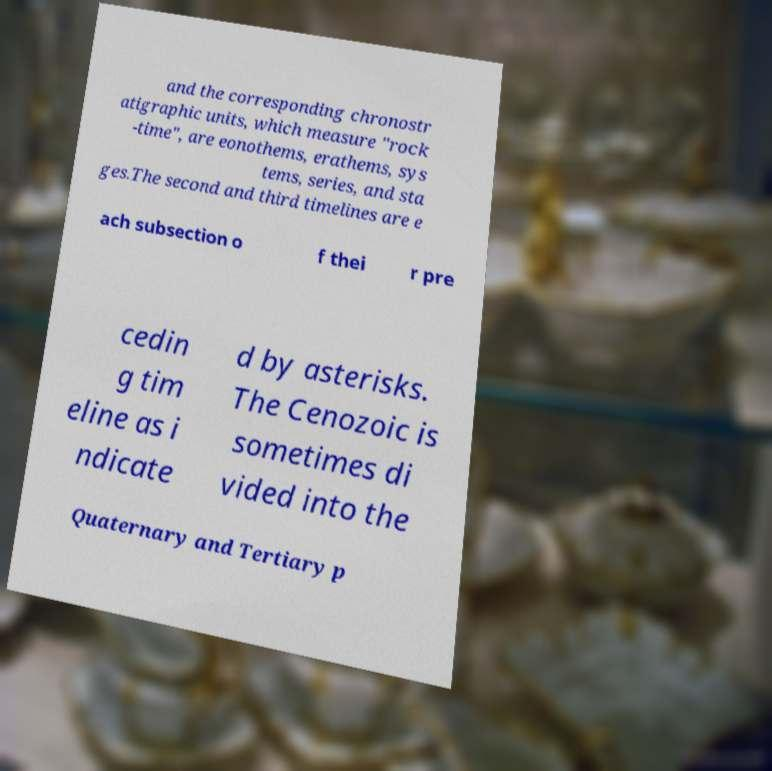I need the written content from this picture converted into text. Can you do that? and the corresponding chronostr atigraphic units, which measure "rock -time", are eonothems, erathems, sys tems, series, and sta ges.The second and third timelines are e ach subsection o f thei r pre cedin g tim eline as i ndicate d by asterisks. The Cenozoic is sometimes di vided into the Quaternary and Tertiary p 